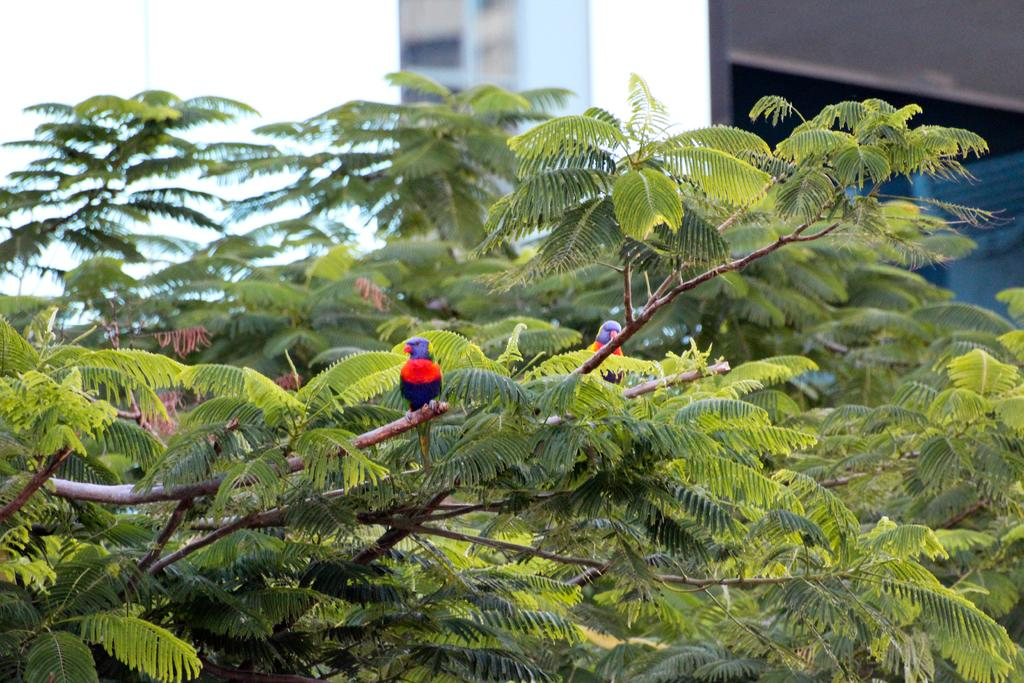How many birds can be seen in the image? There are two birds in the image. Where are the birds located? The birds are standing on the branches of a tree. What can be seen in the background of the image? There is a building in the background of the image. What type of shoes are hanging from the hook in the image? There is no hook or shoes present in the image. What is the plot of the story being told in the image? The image does not depict a story or plot; it simply shows two birds on a tree branch with a building in the background. 